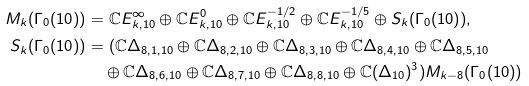Convert formula to latex. <formula><loc_0><loc_0><loc_500><loc_500>M _ { k } ( \Gamma _ { 0 } ( 1 0 ) ) & = \mathbb { C } E _ { k , 1 0 } ^ { \infty } \oplus \mathbb { C } E _ { k , 1 0 } ^ { 0 } \oplus \mathbb { C } E _ { k , 1 0 } ^ { - 1 / 2 } \oplus \mathbb { C } E _ { k , 1 0 } ^ { - 1 / 5 } \oplus S _ { k } ( \Gamma _ { 0 } ( 1 0 ) ) , \\ S _ { k } ( \Gamma _ { 0 } ( 1 0 ) ) & = ( \mathbb { C } \Delta _ { 8 , 1 , 1 0 } \oplus \mathbb { C } \Delta _ { 8 , 2 , 1 0 } \oplus \mathbb { C } \Delta _ { 8 , 3 , 1 0 } \oplus \mathbb { C } \Delta _ { 8 , 4 , 1 0 } \oplus \mathbb { C } \Delta _ { 8 , 5 , 1 0 } \\ & \quad \oplus \mathbb { C } \Delta _ { 8 , 6 , 1 0 } \oplus \mathbb { C } \Delta _ { 8 , 7 , 1 0 } \oplus \mathbb { C } \Delta _ { 8 , 8 , 1 0 } \oplus \mathbb { C } ( \Delta _ { 1 0 } ) ^ { 3 } ) M _ { k - 8 } ( \Gamma _ { 0 } ( 1 0 ) )</formula> 